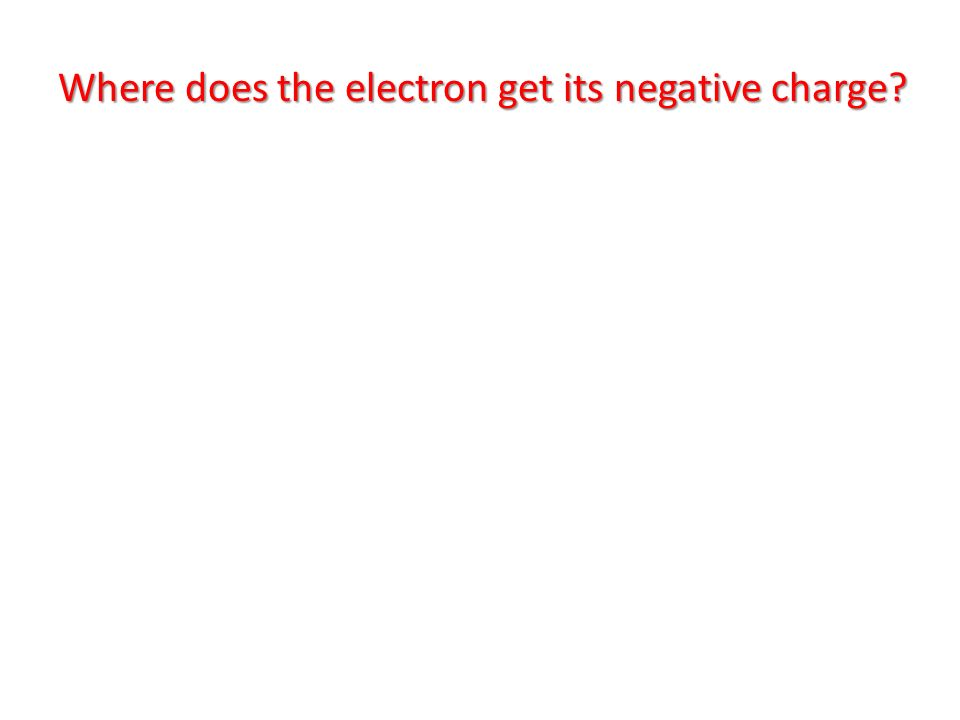How might the immediate visual impact of the red and white color scheme affect a viewer's perception of the urgency or importance of the question? The immediate visual impact of the red and white color scheme can significantly affect a viewer's perception of urgency and importance. Red is psychologically associated with high alertness, danger, and urgency, which can prompt immediate attention. Using white text enhances readability against the bold red background, ensuring that the message is clear and quickly processed. This combination can effectively highlight the critical nature of the question, making it stand out and conveying an urgent need for an answer or consideration. This is particularly useful in contexts requiring immediate attention or action, such as safety notices or important announcements. In what scenarios might this color scheme be less effective or even counterproductive? While the red and white color scheme is effective in drawing attention, there are scenarios where it might be less effective or counterproductive. For instance, overuse of such a color scheme can lead to desensitization, where viewers start to ignore it due to constant exposure. Additionally, in contexts where calm and focus are required, such as in relaxation or medical environments, the aggressive nature of red might cause unnecessary stress or anxiety. Furthermore, for individuals with certain visual impairments, such as color blindness, the red may not stand out as intended, diminishing the overall impact. Therefore, it is essential to use this color scheme judiciously, considering the context and audience. 